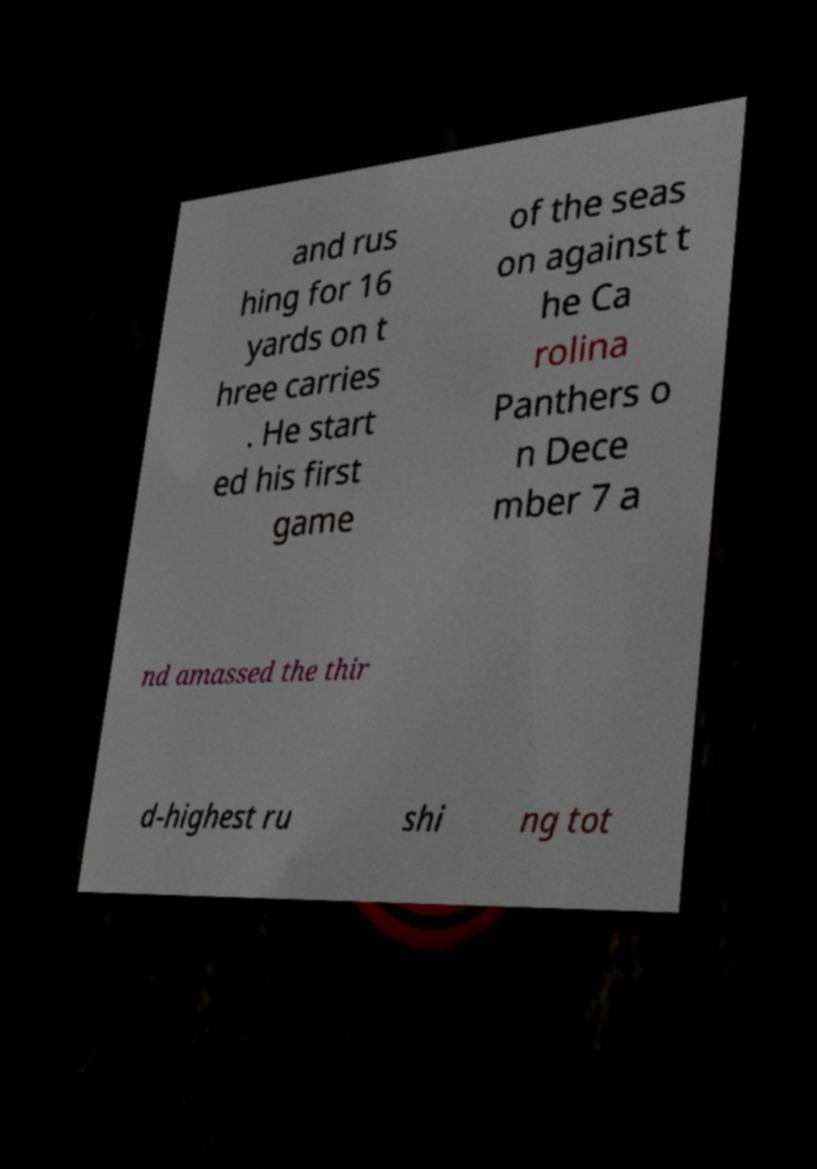Could you extract and type out the text from this image? and rus hing for 16 yards on t hree carries . He start ed his first game of the seas on against t he Ca rolina Panthers o n Dece mber 7 a nd amassed the thir d-highest ru shi ng tot 